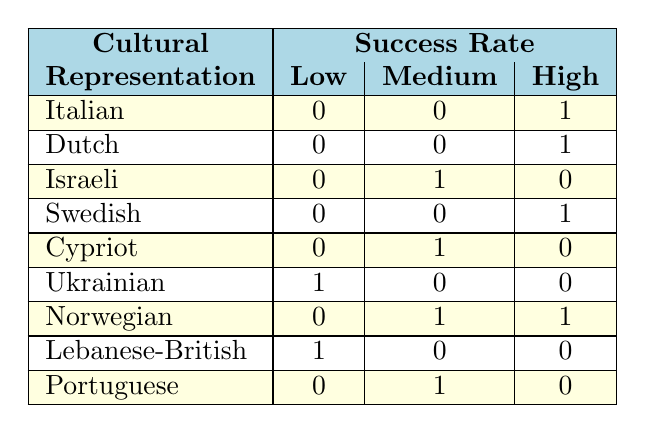What is the cultural representation of the song "Zitti e buoni"? The table shows that the song "Zitti e buoni" is listed under the row for the Italian cultural representation.
Answer: Italian How many songs have a high success rate? To find this, we look for rows marked with "High" under the success rate column. The songs "Zitti e buoni," "Arcade," "Euphoria," and "Spirit in the Sky" have a high success rate, totaling 4 songs.
Answer: 4 Is there any song representation with a low success rate? By checking the table, we see that both Ukrainian and Lebanese-British representations have songs marked with a low success rate. Therefore, the statement is true.
Answer: Yes How many cultural representations have a medium success rate? We can count the rows that have "Medium" marked under the success rate column. They are the songs by Netta (Israeli), Elena Tsagrinou (Cypriot), Hanne Sørvaag (Norwegian), and Eduardo Nascimento (Portuguese), giving a total of 4 representations.
Answer: 4 Which cultural representation has the highest number of songs with a low success rate? Looking through the table, the Ukrainian representation has 1 song with a low success rate. Both the Lebanese-British representation also has 1 song; they are equal but are the highest in the count of low success rate songs.
Answer: Ukrainian and Lebanese-British How many songs from Norwegian representation were successful? The table shows two Norwegian songs: one has a medium success rate and the other has a high success rate, so we add one from the medium and one from the high, which gives us a total of 2 successful songs.
Answer: 2 Are there any cultural representations that did not complete the table for the 'Low' success rate? The table indicates that the only cultural representation without any participant in the 'Low' success rate category are the Italian, Dutch, Swedish, Cypriot, and Portuguese songs. Therefore, the statement is true.
Answer: Yes What is the total number of distinct success rates represented in the data? The success rates in the table are Low, Medium, and High. Summing those distinct categories gives us 3 unique success rates.
Answer: 3 Which cultural representation has an equal distribution of success rates across all categories? By checking each category, we see that none of the cultural representations managed to fill all three success rate categories. Thus, there is no equal distribution across all categories.
Answer: None 